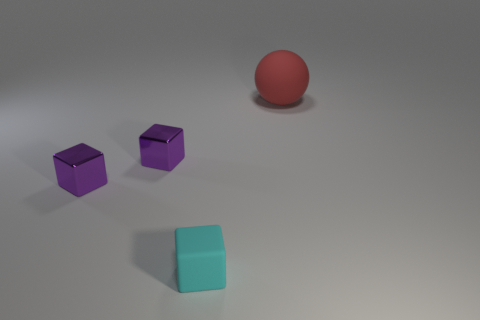Subtract all purple cubes. How many were subtracted if there are1purple cubes left? 1 Subtract all gray balls. Subtract all yellow blocks. How many balls are left? 1 Add 2 rubber objects. How many objects exist? 6 Subtract all balls. How many objects are left? 3 Add 4 matte blocks. How many matte blocks exist? 5 Subtract 0 gray blocks. How many objects are left? 4 Subtract all big cyan rubber spheres. Subtract all small metal things. How many objects are left? 2 Add 4 purple metal cubes. How many purple metal cubes are left? 6 